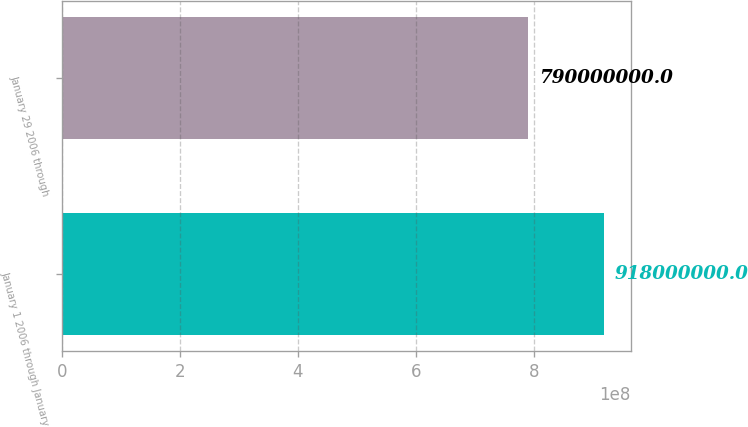Convert chart to OTSL. <chart><loc_0><loc_0><loc_500><loc_500><bar_chart><fcel>January 1 2006 through January<fcel>January 29 2006 through<nl><fcel>9.18e+08<fcel>7.9e+08<nl></chart> 